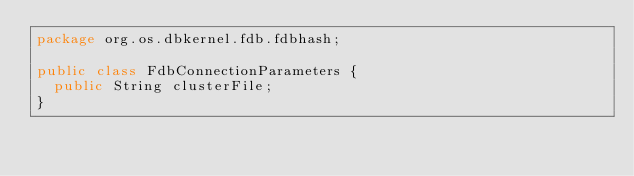Convert code to text. <code><loc_0><loc_0><loc_500><loc_500><_Java_>package org.os.dbkernel.fdb.fdbhash;

public class FdbConnectionParameters {
  public String clusterFile;
}
</code> 